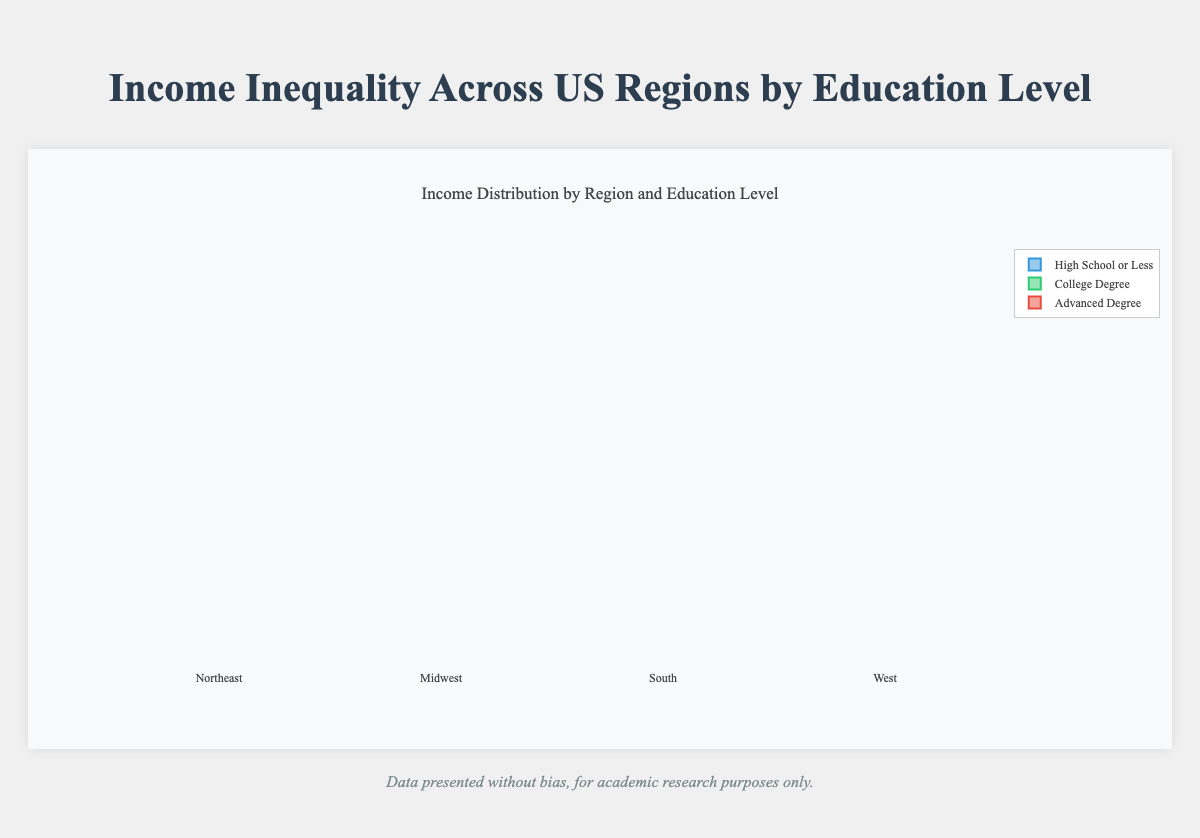Which region has the highest income for individuals with an advanced degree? To identify the region with the highest income for individuals with an advanced degree, we observe the groups representing advanced degree incomes in each region. The West has figures [74000, 76000, 75000, 73000, 74500], which are higher than other regions. Hence, the West region has the highest income for individuals with advanced degrees.
Answer: West What is the range of incomes for the High School or Less group in the South region? First, identify the minimum and maximum income values in the South region's "High School or Less" group, which are 23000 and 26000, respectively. The income range is calculated as the difference between the maximum and minimum values.
Answer: 3000 Which education level shows the largest spread in income within the Midwest region? To determine the largest spread in income, we need to compare the ranges of incomes across different education levels in the Midwest: "High School or Less" (range: 29000 - 25000 = 4000), "College Degree" (range: 47000 - 44000 = 3000), and "Advanced Degree" (range: 67000 - 64000 = 3000). The largest spread is in the High School or Less group, with a range of 4000.
Answer: High School or Less How does the median income for individuals with a college degree in the Northeast compare to those in the South? The median income is the middle value when the values are ordered. In the Northeast, incomes for individuals with a college degree are [48000, 49500, 50000, 51000, 52000] with a median of 50000. In the South, they are [39000, 40000, 40500, 41000, 42000] with a median of 40500. The median income is higher in the Northeast.
Answer: Higher in Northeast What is the interquartile range (IQR) for individuals with high school education or less in the West region? To find the IQR, we determine the first quartile (Q1) and the third quartile (Q3). For the West region's "High School or Less" group (33000, 32000, 33500, 34000, 35000), Q1 is 33000, Q3 is 34000. The IQR is Q3-Q1 = 34000 - 33000 = 1000.
Answer: 1000 